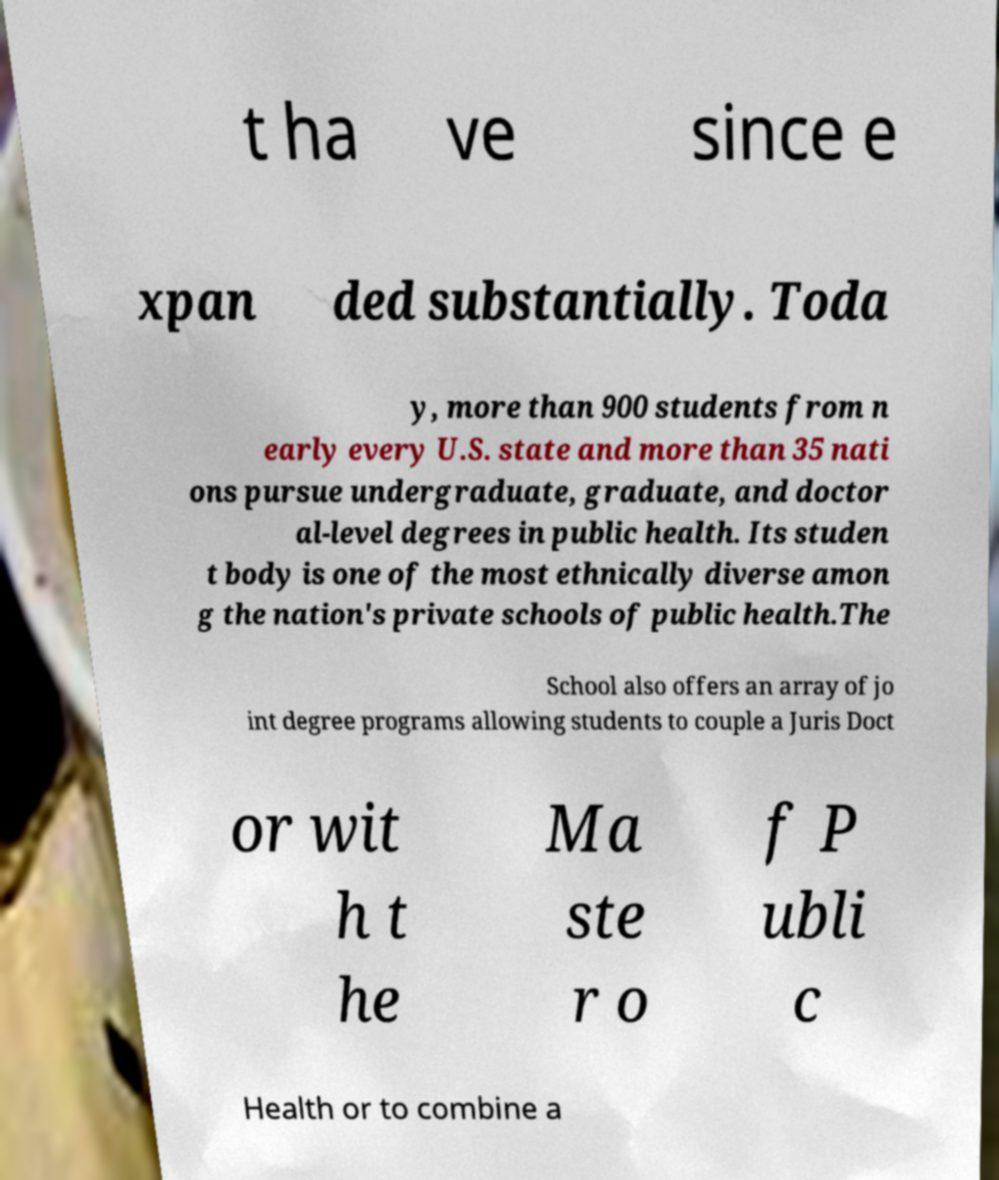There's text embedded in this image that I need extracted. Can you transcribe it verbatim? t ha ve since e xpan ded substantially. Toda y, more than 900 students from n early every U.S. state and more than 35 nati ons pursue undergraduate, graduate, and doctor al-level degrees in public health. Its studen t body is one of the most ethnically diverse amon g the nation's private schools of public health.The School also offers an array of jo int degree programs allowing students to couple a Juris Doct or wit h t he Ma ste r o f P ubli c Health or to combine a 